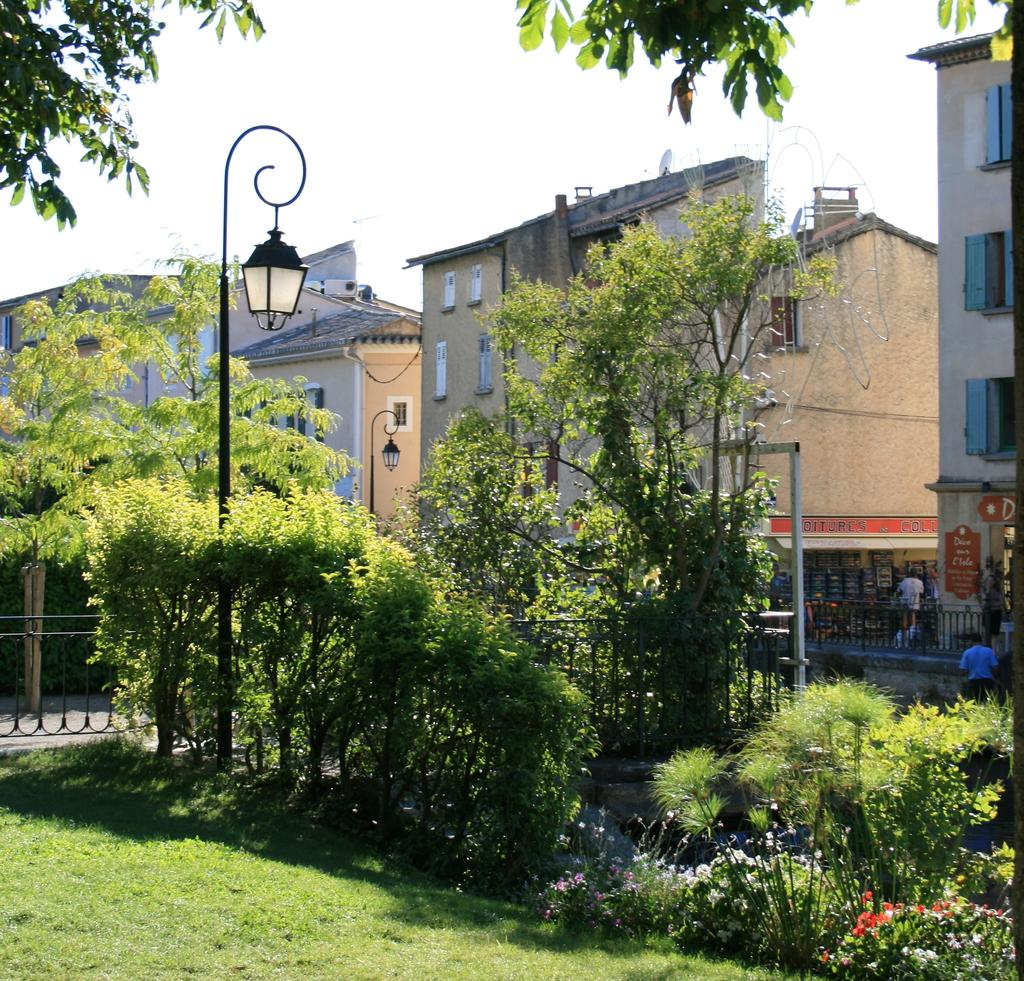What type of structures can be seen in the image? There are buildings with windows in the image. What is on the ground in the image? The ground has grass in the image. What are the poles used for in the image? The poles are likely used for supporting lights or other objects in the image. What type of establishment is present in the image? There is a store in the image. Are there any living organisms visible in the image? Yes, there are people visible in the image. What type of vegetation is present in the image? There are trees in the image. What part of the natural environment is visible in the image? The sky is visible in the image. What type of glass is used to make the liquid in the image? There is no glass or liquid present in the image. How does the society depicted in the image function? The image does not depict a society, so it is not possible to determine how it functions. 